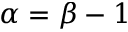<formula> <loc_0><loc_0><loc_500><loc_500>\alpha = \beta - 1</formula> 